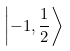Convert formula to latex. <formula><loc_0><loc_0><loc_500><loc_500>\left | - 1 , { \frac { 1 } { 2 } } \right \rangle</formula> 